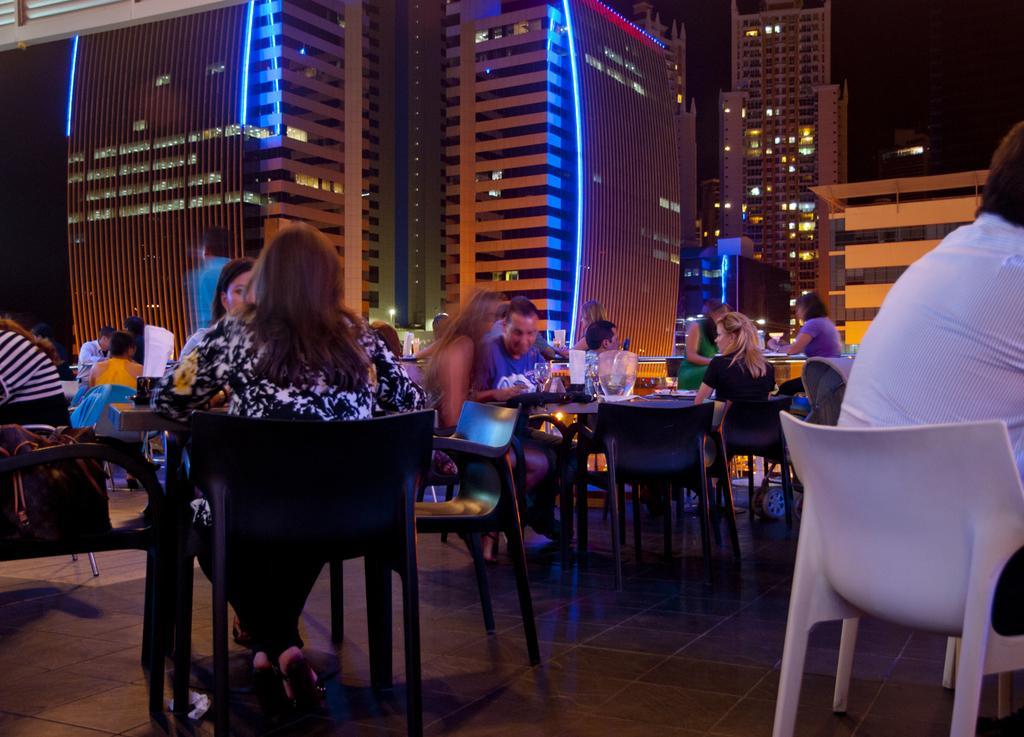Please provide a concise description of this image. there are so many people sitting around it tables with food in it and speaking amount them behind then there is a big building with the lights. 